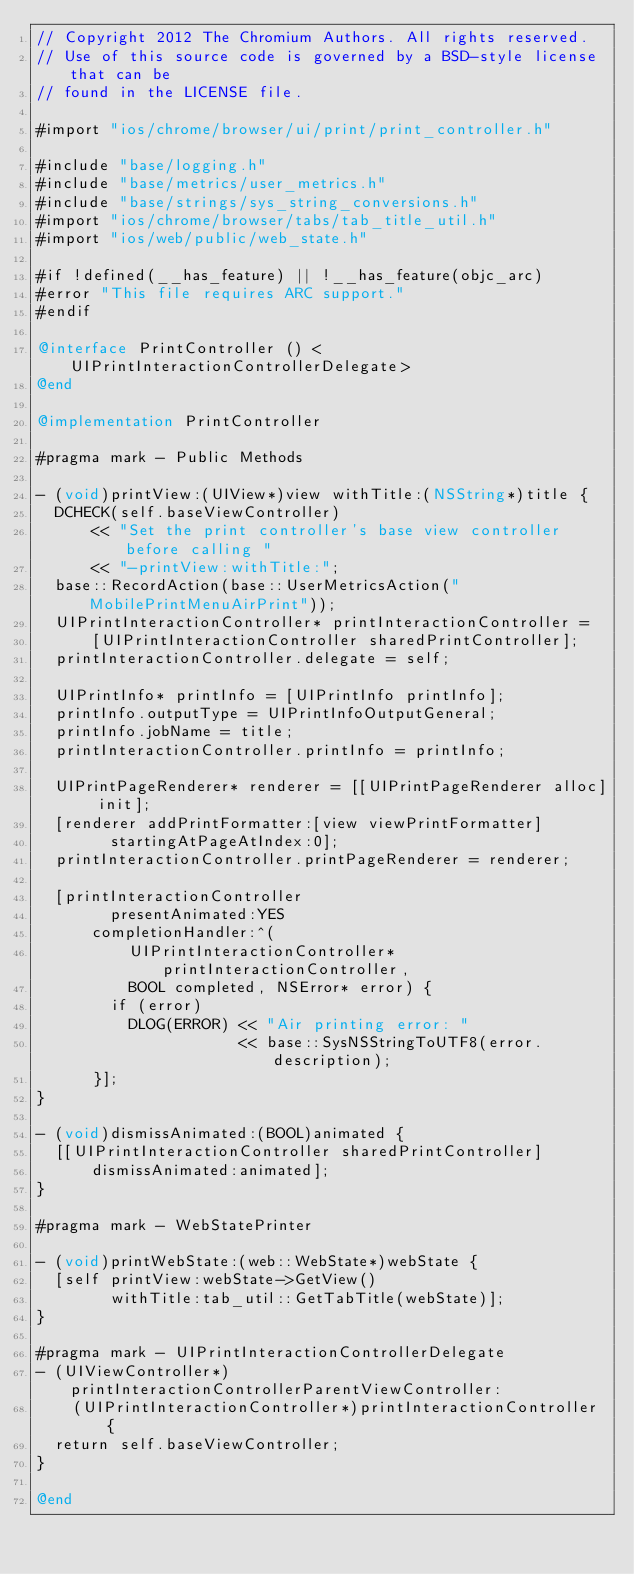<code> <loc_0><loc_0><loc_500><loc_500><_ObjectiveC_>// Copyright 2012 The Chromium Authors. All rights reserved.
// Use of this source code is governed by a BSD-style license that can be
// found in the LICENSE file.

#import "ios/chrome/browser/ui/print/print_controller.h"

#include "base/logging.h"
#include "base/metrics/user_metrics.h"
#include "base/strings/sys_string_conversions.h"
#import "ios/chrome/browser/tabs/tab_title_util.h"
#import "ios/web/public/web_state.h"

#if !defined(__has_feature) || !__has_feature(objc_arc)
#error "This file requires ARC support."
#endif

@interface PrintController () <UIPrintInteractionControllerDelegate>
@end

@implementation PrintController

#pragma mark - Public Methods

- (void)printView:(UIView*)view withTitle:(NSString*)title {
  DCHECK(self.baseViewController)
      << "Set the print controller's base view controller before calling "
      << "-printView:withTitle:";
  base::RecordAction(base::UserMetricsAction("MobilePrintMenuAirPrint"));
  UIPrintInteractionController* printInteractionController =
      [UIPrintInteractionController sharedPrintController];
  printInteractionController.delegate = self;

  UIPrintInfo* printInfo = [UIPrintInfo printInfo];
  printInfo.outputType = UIPrintInfoOutputGeneral;
  printInfo.jobName = title;
  printInteractionController.printInfo = printInfo;

  UIPrintPageRenderer* renderer = [[UIPrintPageRenderer alloc] init];
  [renderer addPrintFormatter:[view viewPrintFormatter]
        startingAtPageAtIndex:0];
  printInteractionController.printPageRenderer = renderer;

  [printInteractionController
        presentAnimated:YES
      completionHandler:^(
          UIPrintInteractionController* printInteractionController,
          BOOL completed, NSError* error) {
        if (error)
          DLOG(ERROR) << "Air printing error: "
                      << base::SysNSStringToUTF8(error.description);
      }];
}

- (void)dismissAnimated:(BOOL)animated {
  [[UIPrintInteractionController sharedPrintController]
      dismissAnimated:animated];
}

#pragma mark - WebStatePrinter

- (void)printWebState:(web::WebState*)webState {
  [self printView:webState->GetView()
        withTitle:tab_util::GetTabTitle(webState)];
}

#pragma mark - UIPrintInteractionControllerDelegate
- (UIViewController*)printInteractionControllerParentViewController:
    (UIPrintInteractionController*)printInteractionController {
  return self.baseViewController;
}

@end
</code> 